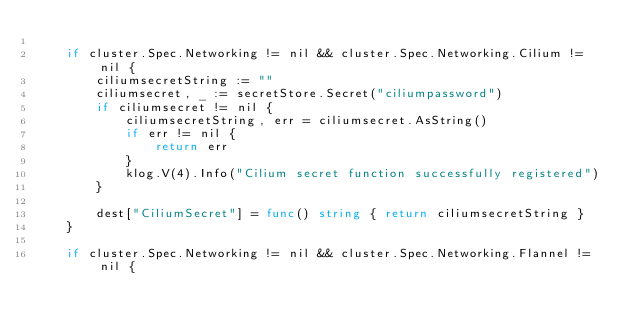Convert code to text. <code><loc_0><loc_0><loc_500><loc_500><_Go_>
	if cluster.Spec.Networking != nil && cluster.Spec.Networking.Cilium != nil {
		ciliumsecretString := ""
		ciliumsecret, _ := secretStore.Secret("ciliumpassword")
		if ciliumsecret != nil {
			ciliumsecretString, err = ciliumsecret.AsString()
			if err != nil {
				return err
			}
			klog.V(4).Info("Cilium secret function successfully registered")
		}

		dest["CiliumSecret"] = func() string { return ciliumsecretString }
	}

	if cluster.Spec.Networking != nil && cluster.Spec.Networking.Flannel != nil {</code> 